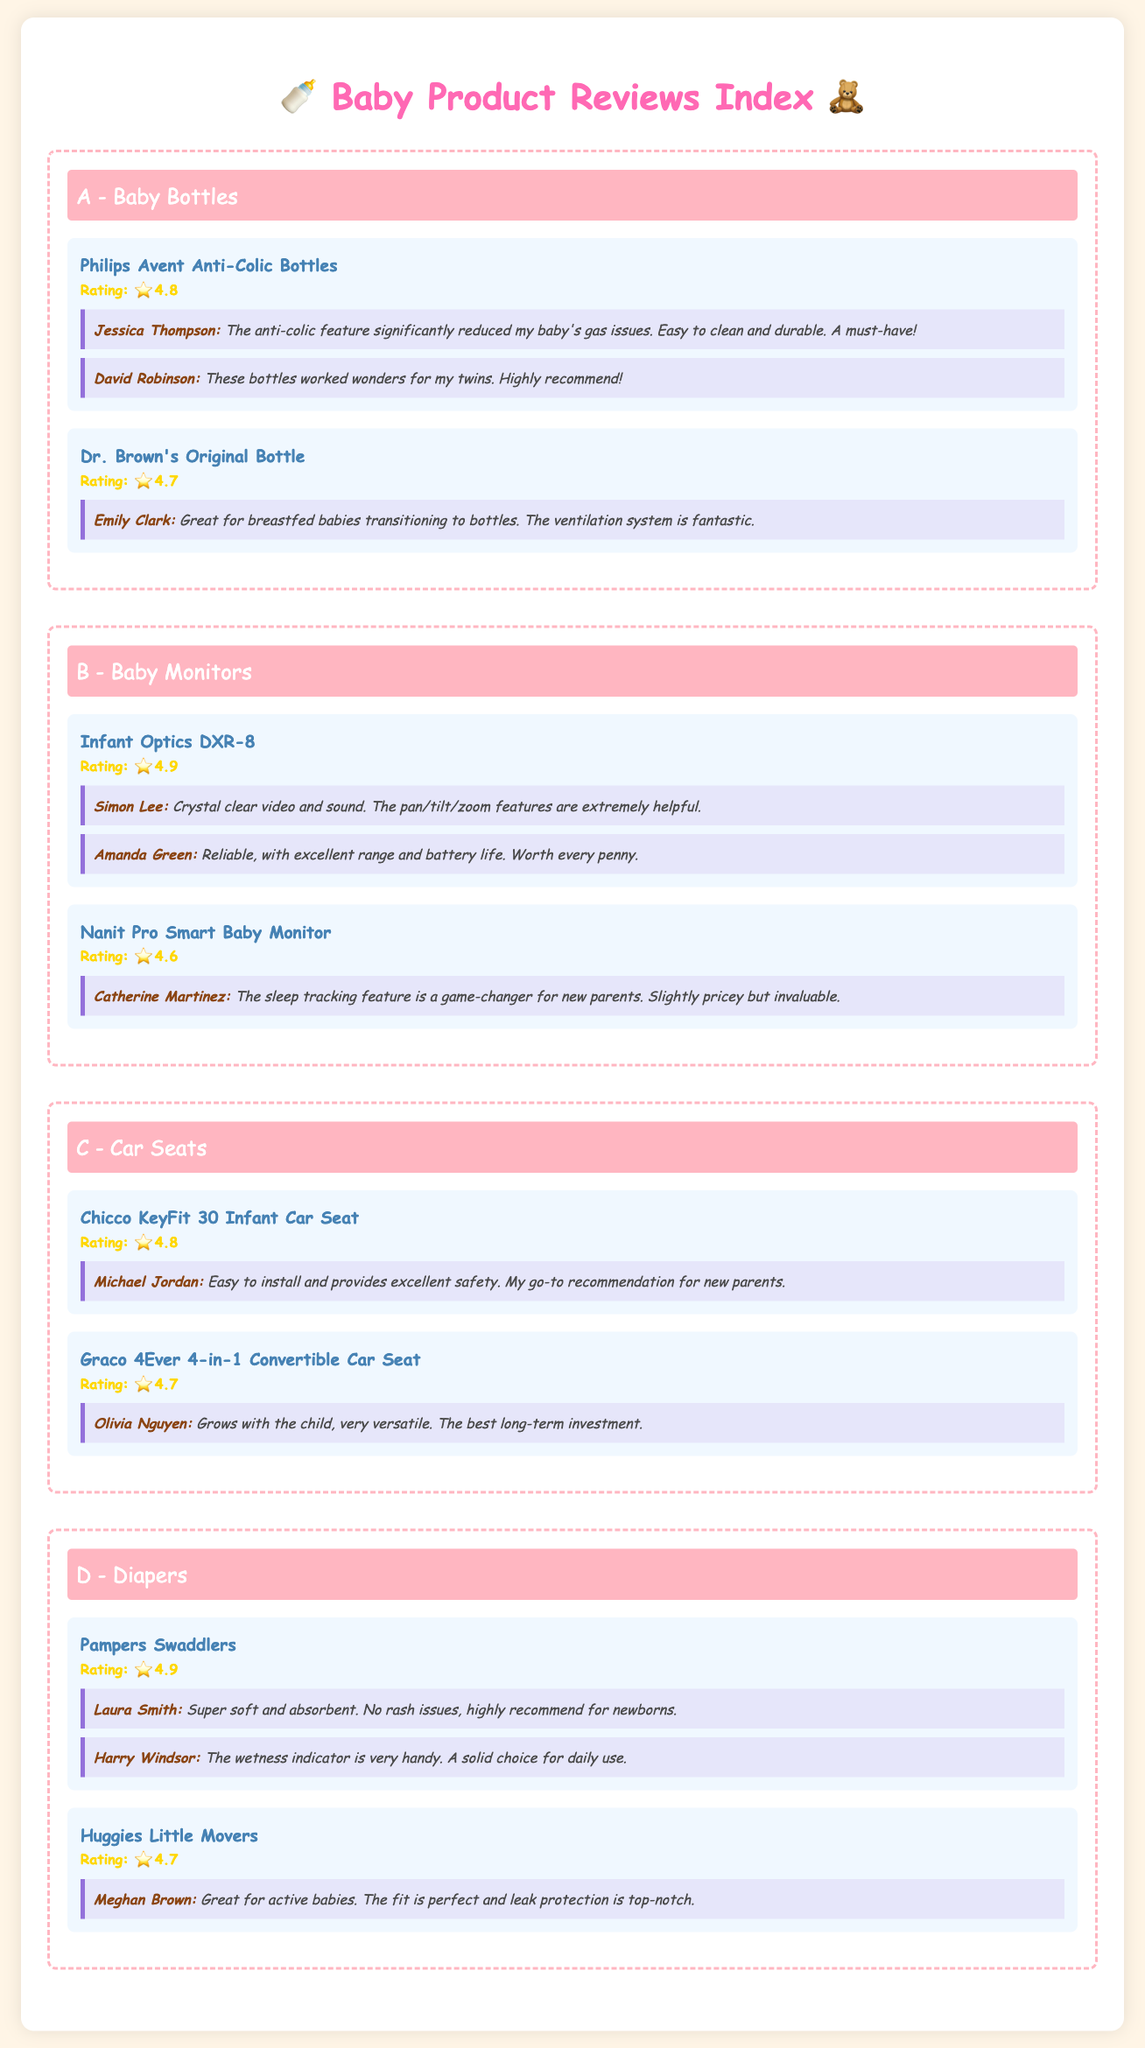What is the highest rating for a baby bottle? The highest rating for a baby bottle in the document is 4.8 for the Philips Avent Anti-Colic Bottles.
Answer: 4.8 Who recommends the Graco 4Ever 4-in-1 Convertible Car Seat? The Graco 4Ever 4-in-1 Convertible Car Seat is recommended by Olivia Nguyen.
Answer: Olivia Nguyen How many products are listed under Baby Monitors? There are two products listed under Baby Monitors: Infant Optics DXR-8 and Nanit Pro Smart Baby Monitor.
Answer: 2 What is the overall rating of Pampers Swaddlers? The overall rating of Pampers Swaddlers is 4.9.
Answer: 4.9 Which baby monitor has a testimonial mentioning sleep tracking? The Nanit Pro Smart Baby Monitor has a testimonial mentioning the sleep tracking feature.
Answer: Nanit Pro Smart Baby Monitor What is the primary feature highlighted in the testimonial for the Philips Avent Anti-Colic Bottles? The primary feature highlighted is the anti-colic feature that reduced gas issues.
Answer: Anti-colic feature Which diaper is noted for having a wetness indicator? The Pampers Swaddlers diaper is noted for having a wetness indicator.
Answer: Pampers Swaddlers What is the rating of Dr. Brown's Original Bottle? The rating of Dr. Brown's Original Bottle is 4.7.
Answer: 4.7 